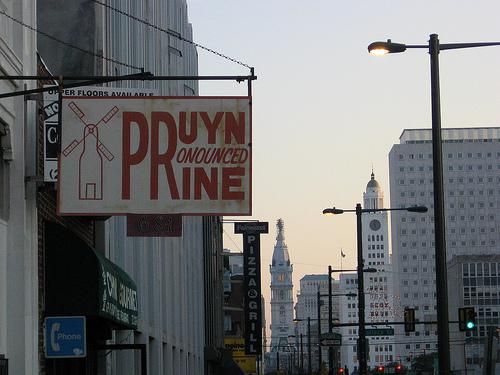Question: where is this taken?
Choices:
A. Outside of a store.
B. Outside of a flea market.
C. Outside of a farmer's market.
D. Outside of PRounouced shop.
Answer with the letter. Answer: D Question: when is this picture taken?
Choices:
A. Day time.
B. Evening.
C. Dusk.
D. Afternoon.
Answer with the letter. Answer: C Question: what colors are the building?
Choices:
A. Grey.
B. Tan.
C. Beige.
D. White.
Answer with the letter. Answer: D Question: what does the black sign say?
Choices:
A. Go away.
B. Please stop here.
C. Pizza Grill.
D. Do not enter.
Answer with the letter. Answer: C 